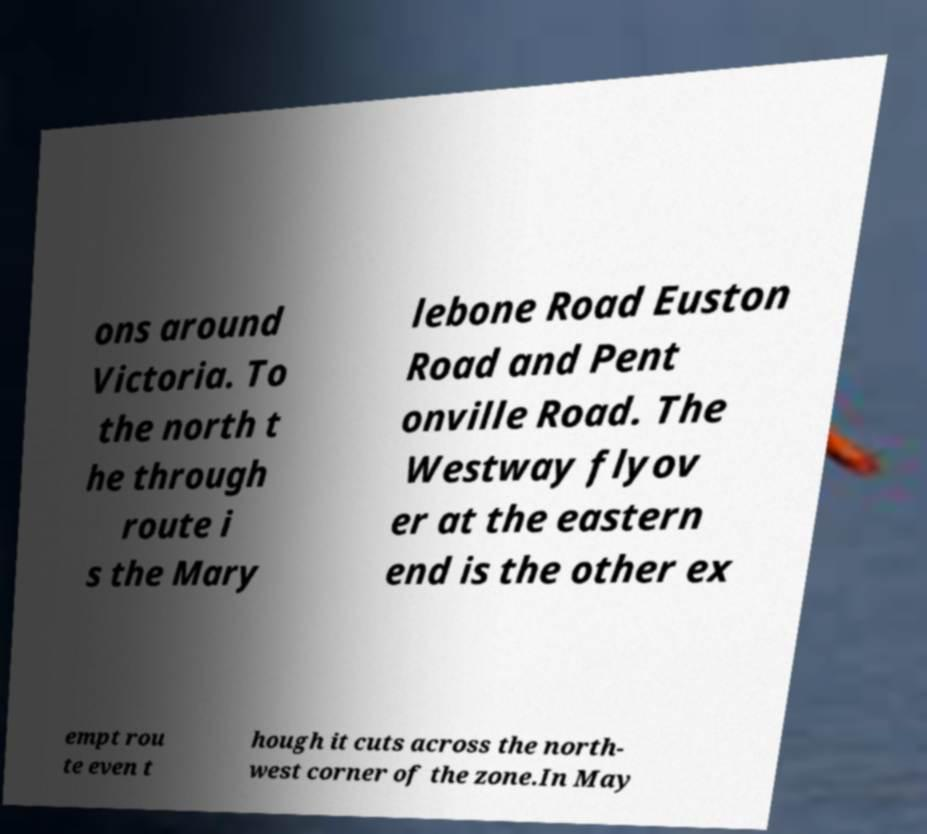Can you read and provide the text displayed in the image?This photo seems to have some interesting text. Can you extract and type it out for me? ons around Victoria. To the north t he through route i s the Mary lebone Road Euston Road and Pent onville Road. The Westway flyov er at the eastern end is the other ex empt rou te even t hough it cuts across the north- west corner of the zone.In May 